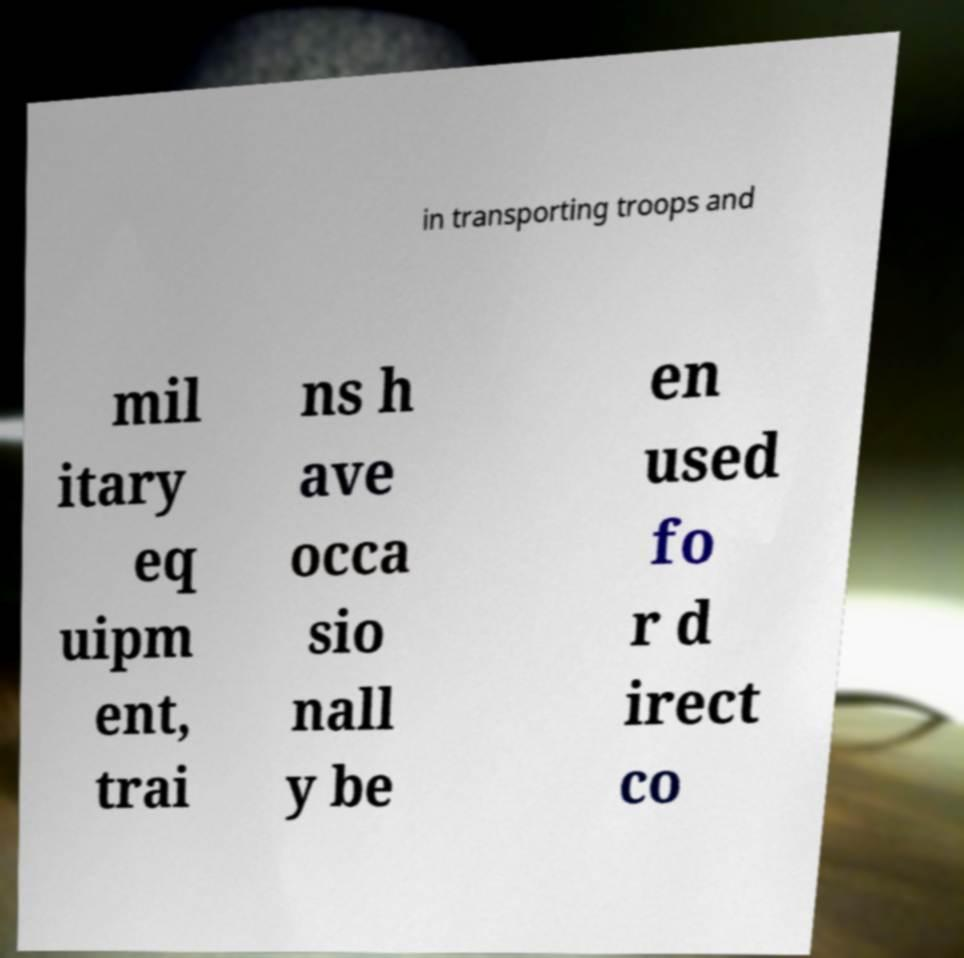What messages or text are displayed in this image? I need them in a readable, typed format. in transporting troops and mil itary eq uipm ent, trai ns h ave occa sio nall y be en used fo r d irect co 